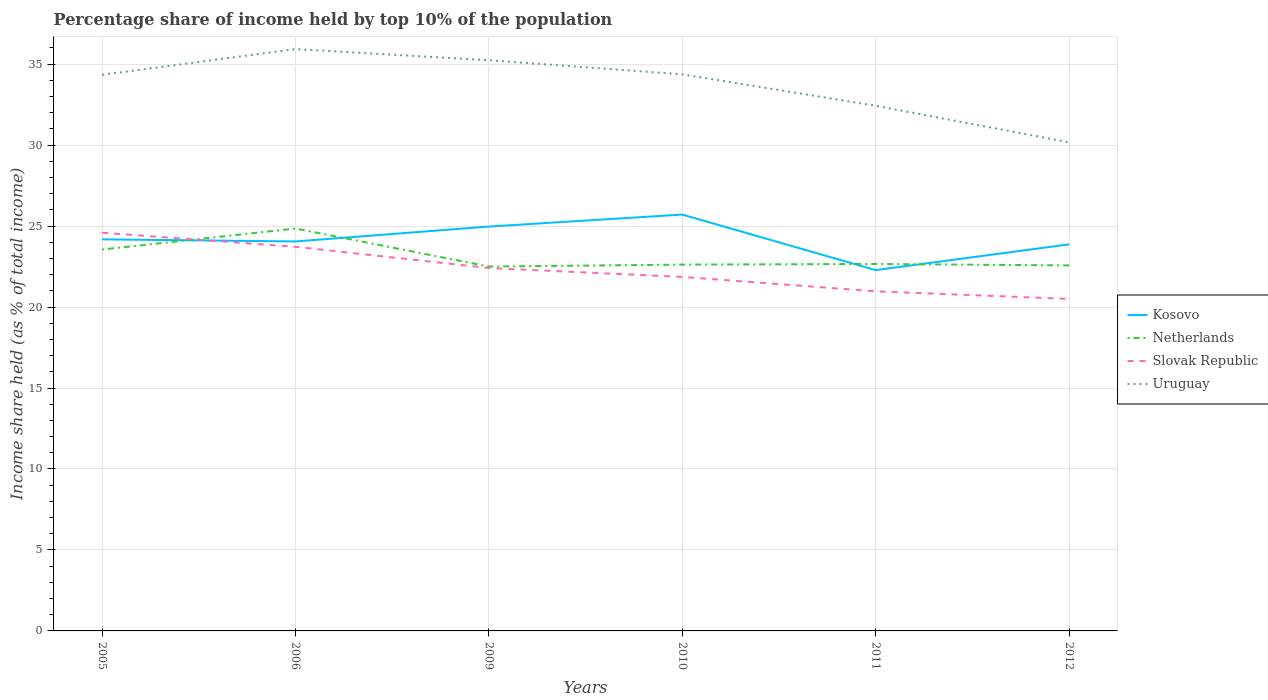Does the line corresponding to Uruguay intersect with the line corresponding to Kosovo?
Ensure brevity in your answer.  No. Is the number of lines equal to the number of legend labels?
Your response must be concise. Yes. Across all years, what is the maximum percentage share of income held by top 10% of the population in Kosovo?
Make the answer very short. 22.28. What is the total percentage share of income held by top 10% of the population in Slovak Republic in the graph?
Your response must be concise. 0.89. What is the difference between the highest and the second highest percentage share of income held by top 10% of the population in Slovak Republic?
Make the answer very short. 4.09. Is the percentage share of income held by top 10% of the population in Kosovo strictly greater than the percentage share of income held by top 10% of the population in Netherlands over the years?
Your answer should be very brief. No. How many lines are there?
Keep it short and to the point. 4. What is the difference between two consecutive major ticks on the Y-axis?
Your answer should be very brief. 5. Does the graph contain grids?
Ensure brevity in your answer.  Yes. Where does the legend appear in the graph?
Offer a very short reply. Center right. How are the legend labels stacked?
Offer a terse response. Vertical. What is the title of the graph?
Provide a succinct answer. Percentage share of income held by top 10% of the population. What is the label or title of the Y-axis?
Your answer should be very brief. Income share held (as % of total income). What is the Income share held (as % of total income) in Kosovo in 2005?
Your answer should be very brief. 24.18. What is the Income share held (as % of total income) of Netherlands in 2005?
Give a very brief answer. 23.55. What is the Income share held (as % of total income) in Slovak Republic in 2005?
Your answer should be compact. 24.59. What is the Income share held (as % of total income) of Uruguay in 2005?
Give a very brief answer. 34.34. What is the Income share held (as % of total income) in Kosovo in 2006?
Provide a succinct answer. 24.05. What is the Income share held (as % of total income) of Netherlands in 2006?
Keep it short and to the point. 24.85. What is the Income share held (as % of total income) of Slovak Republic in 2006?
Give a very brief answer. 23.72. What is the Income share held (as % of total income) in Uruguay in 2006?
Offer a terse response. 35.93. What is the Income share held (as % of total income) of Kosovo in 2009?
Make the answer very short. 24.97. What is the Income share held (as % of total income) in Slovak Republic in 2009?
Offer a very short reply. 22.41. What is the Income share held (as % of total income) of Uruguay in 2009?
Offer a terse response. 35.24. What is the Income share held (as % of total income) in Kosovo in 2010?
Your answer should be very brief. 25.71. What is the Income share held (as % of total income) in Netherlands in 2010?
Provide a short and direct response. 22.62. What is the Income share held (as % of total income) of Slovak Republic in 2010?
Provide a short and direct response. 21.86. What is the Income share held (as % of total income) of Uruguay in 2010?
Ensure brevity in your answer.  34.37. What is the Income share held (as % of total income) in Kosovo in 2011?
Ensure brevity in your answer.  22.28. What is the Income share held (as % of total income) in Netherlands in 2011?
Provide a succinct answer. 22.66. What is the Income share held (as % of total income) in Slovak Republic in 2011?
Give a very brief answer. 20.97. What is the Income share held (as % of total income) in Uruguay in 2011?
Offer a terse response. 32.43. What is the Income share held (as % of total income) in Kosovo in 2012?
Your response must be concise. 23.87. What is the Income share held (as % of total income) in Netherlands in 2012?
Provide a succinct answer. 22.57. What is the Income share held (as % of total income) of Uruguay in 2012?
Keep it short and to the point. 30.17. Across all years, what is the maximum Income share held (as % of total income) in Kosovo?
Your response must be concise. 25.71. Across all years, what is the maximum Income share held (as % of total income) in Netherlands?
Your response must be concise. 24.85. Across all years, what is the maximum Income share held (as % of total income) in Slovak Republic?
Offer a very short reply. 24.59. Across all years, what is the maximum Income share held (as % of total income) of Uruguay?
Your answer should be very brief. 35.93. Across all years, what is the minimum Income share held (as % of total income) in Kosovo?
Your answer should be very brief. 22.28. Across all years, what is the minimum Income share held (as % of total income) in Slovak Republic?
Ensure brevity in your answer.  20.5. Across all years, what is the minimum Income share held (as % of total income) of Uruguay?
Give a very brief answer. 30.17. What is the total Income share held (as % of total income) in Kosovo in the graph?
Your response must be concise. 145.06. What is the total Income share held (as % of total income) in Netherlands in the graph?
Offer a very short reply. 138.75. What is the total Income share held (as % of total income) in Slovak Republic in the graph?
Provide a short and direct response. 134.05. What is the total Income share held (as % of total income) in Uruguay in the graph?
Your answer should be compact. 202.48. What is the difference between the Income share held (as % of total income) in Kosovo in 2005 and that in 2006?
Offer a very short reply. 0.13. What is the difference between the Income share held (as % of total income) of Slovak Republic in 2005 and that in 2006?
Your answer should be very brief. 0.87. What is the difference between the Income share held (as % of total income) in Uruguay in 2005 and that in 2006?
Keep it short and to the point. -1.59. What is the difference between the Income share held (as % of total income) in Kosovo in 2005 and that in 2009?
Provide a short and direct response. -0.79. What is the difference between the Income share held (as % of total income) in Netherlands in 2005 and that in 2009?
Your answer should be compact. 1.05. What is the difference between the Income share held (as % of total income) in Slovak Republic in 2005 and that in 2009?
Provide a succinct answer. 2.18. What is the difference between the Income share held (as % of total income) of Uruguay in 2005 and that in 2009?
Make the answer very short. -0.9. What is the difference between the Income share held (as % of total income) of Kosovo in 2005 and that in 2010?
Keep it short and to the point. -1.53. What is the difference between the Income share held (as % of total income) in Slovak Republic in 2005 and that in 2010?
Offer a terse response. 2.73. What is the difference between the Income share held (as % of total income) in Uruguay in 2005 and that in 2010?
Your answer should be very brief. -0.03. What is the difference between the Income share held (as % of total income) in Kosovo in 2005 and that in 2011?
Keep it short and to the point. 1.9. What is the difference between the Income share held (as % of total income) of Netherlands in 2005 and that in 2011?
Your response must be concise. 0.89. What is the difference between the Income share held (as % of total income) in Slovak Republic in 2005 and that in 2011?
Offer a terse response. 3.62. What is the difference between the Income share held (as % of total income) in Uruguay in 2005 and that in 2011?
Provide a succinct answer. 1.91. What is the difference between the Income share held (as % of total income) of Kosovo in 2005 and that in 2012?
Offer a very short reply. 0.31. What is the difference between the Income share held (as % of total income) of Netherlands in 2005 and that in 2012?
Offer a very short reply. 0.98. What is the difference between the Income share held (as % of total income) of Slovak Republic in 2005 and that in 2012?
Make the answer very short. 4.09. What is the difference between the Income share held (as % of total income) in Uruguay in 2005 and that in 2012?
Your answer should be compact. 4.17. What is the difference between the Income share held (as % of total income) of Kosovo in 2006 and that in 2009?
Offer a terse response. -0.92. What is the difference between the Income share held (as % of total income) of Netherlands in 2006 and that in 2009?
Provide a succinct answer. 2.35. What is the difference between the Income share held (as % of total income) of Slovak Republic in 2006 and that in 2009?
Your answer should be compact. 1.31. What is the difference between the Income share held (as % of total income) in Uruguay in 2006 and that in 2009?
Offer a very short reply. 0.69. What is the difference between the Income share held (as % of total income) in Kosovo in 2006 and that in 2010?
Your response must be concise. -1.66. What is the difference between the Income share held (as % of total income) in Netherlands in 2006 and that in 2010?
Provide a succinct answer. 2.23. What is the difference between the Income share held (as % of total income) of Slovak Republic in 2006 and that in 2010?
Give a very brief answer. 1.86. What is the difference between the Income share held (as % of total income) in Uruguay in 2006 and that in 2010?
Ensure brevity in your answer.  1.56. What is the difference between the Income share held (as % of total income) in Kosovo in 2006 and that in 2011?
Offer a terse response. 1.77. What is the difference between the Income share held (as % of total income) in Netherlands in 2006 and that in 2011?
Your response must be concise. 2.19. What is the difference between the Income share held (as % of total income) in Slovak Republic in 2006 and that in 2011?
Make the answer very short. 2.75. What is the difference between the Income share held (as % of total income) in Kosovo in 2006 and that in 2012?
Give a very brief answer. 0.18. What is the difference between the Income share held (as % of total income) of Netherlands in 2006 and that in 2012?
Your answer should be compact. 2.28. What is the difference between the Income share held (as % of total income) in Slovak Republic in 2006 and that in 2012?
Keep it short and to the point. 3.22. What is the difference between the Income share held (as % of total income) of Uruguay in 2006 and that in 2012?
Offer a terse response. 5.76. What is the difference between the Income share held (as % of total income) of Kosovo in 2009 and that in 2010?
Your answer should be compact. -0.74. What is the difference between the Income share held (as % of total income) of Netherlands in 2009 and that in 2010?
Provide a succinct answer. -0.12. What is the difference between the Income share held (as % of total income) in Slovak Republic in 2009 and that in 2010?
Provide a succinct answer. 0.55. What is the difference between the Income share held (as % of total income) of Uruguay in 2009 and that in 2010?
Provide a succinct answer. 0.87. What is the difference between the Income share held (as % of total income) in Kosovo in 2009 and that in 2011?
Provide a short and direct response. 2.69. What is the difference between the Income share held (as % of total income) in Netherlands in 2009 and that in 2011?
Ensure brevity in your answer.  -0.16. What is the difference between the Income share held (as % of total income) of Slovak Republic in 2009 and that in 2011?
Provide a succinct answer. 1.44. What is the difference between the Income share held (as % of total income) of Uruguay in 2009 and that in 2011?
Your answer should be compact. 2.81. What is the difference between the Income share held (as % of total income) of Netherlands in 2009 and that in 2012?
Give a very brief answer. -0.07. What is the difference between the Income share held (as % of total income) of Slovak Republic in 2009 and that in 2012?
Ensure brevity in your answer.  1.91. What is the difference between the Income share held (as % of total income) in Uruguay in 2009 and that in 2012?
Give a very brief answer. 5.07. What is the difference between the Income share held (as % of total income) of Kosovo in 2010 and that in 2011?
Offer a terse response. 3.43. What is the difference between the Income share held (as % of total income) in Netherlands in 2010 and that in 2011?
Your answer should be compact. -0.04. What is the difference between the Income share held (as % of total income) of Slovak Republic in 2010 and that in 2011?
Ensure brevity in your answer.  0.89. What is the difference between the Income share held (as % of total income) of Uruguay in 2010 and that in 2011?
Keep it short and to the point. 1.94. What is the difference between the Income share held (as % of total income) in Kosovo in 2010 and that in 2012?
Offer a very short reply. 1.84. What is the difference between the Income share held (as % of total income) of Slovak Republic in 2010 and that in 2012?
Provide a succinct answer. 1.36. What is the difference between the Income share held (as % of total income) of Kosovo in 2011 and that in 2012?
Provide a succinct answer. -1.59. What is the difference between the Income share held (as % of total income) in Netherlands in 2011 and that in 2012?
Offer a very short reply. 0.09. What is the difference between the Income share held (as % of total income) in Slovak Republic in 2011 and that in 2012?
Give a very brief answer. 0.47. What is the difference between the Income share held (as % of total income) in Uruguay in 2011 and that in 2012?
Make the answer very short. 2.26. What is the difference between the Income share held (as % of total income) in Kosovo in 2005 and the Income share held (as % of total income) in Netherlands in 2006?
Offer a very short reply. -0.67. What is the difference between the Income share held (as % of total income) in Kosovo in 2005 and the Income share held (as % of total income) in Slovak Republic in 2006?
Make the answer very short. 0.46. What is the difference between the Income share held (as % of total income) of Kosovo in 2005 and the Income share held (as % of total income) of Uruguay in 2006?
Offer a very short reply. -11.75. What is the difference between the Income share held (as % of total income) of Netherlands in 2005 and the Income share held (as % of total income) of Slovak Republic in 2006?
Make the answer very short. -0.17. What is the difference between the Income share held (as % of total income) in Netherlands in 2005 and the Income share held (as % of total income) in Uruguay in 2006?
Provide a short and direct response. -12.38. What is the difference between the Income share held (as % of total income) of Slovak Republic in 2005 and the Income share held (as % of total income) of Uruguay in 2006?
Your response must be concise. -11.34. What is the difference between the Income share held (as % of total income) in Kosovo in 2005 and the Income share held (as % of total income) in Netherlands in 2009?
Your answer should be compact. 1.68. What is the difference between the Income share held (as % of total income) of Kosovo in 2005 and the Income share held (as % of total income) of Slovak Republic in 2009?
Your answer should be compact. 1.77. What is the difference between the Income share held (as % of total income) of Kosovo in 2005 and the Income share held (as % of total income) of Uruguay in 2009?
Your answer should be very brief. -11.06. What is the difference between the Income share held (as % of total income) in Netherlands in 2005 and the Income share held (as % of total income) in Slovak Republic in 2009?
Your response must be concise. 1.14. What is the difference between the Income share held (as % of total income) of Netherlands in 2005 and the Income share held (as % of total income) of Uruguay in 2009?
Offer a terse response. -11.69. What is the difference between the Income share held (as % of total income) in Slovak Republic in 2005 and the Income share held (as % of total income) in Uruguay in 2009?
Give a very brief answer. -10.65. What is the difference between the Income share held (as % of total income) in Kosovo in 2005 and the Income share held (as % of total income) in Netherlands in 2010?
Provide a short and direct response. 1.56. What is the difference between the Income share held (as % of total income) of Kosovo in 2005 and the Income share held (as % of total income) of Slovak Republic in 2010?
Your answer should be very brief. 2.32. What is the difference between the Income share held (as % of total income) in Kosovo in 2005 and the Income share held (as % of total income) in Uruguay in 2010?
Offer a very short reply. -10.19. What is the difference between the Income share held (as % of total income) of Netherlands in 2005 and the Income share held (as % of total income) of Slovak Republic in 2010?
Your answer should be compact. 1.69. What is the difference between the Income share held (as % of total income) in Netherlands in 2005 and the Income share held (as % of total income) in Uruguay in 2010?
Offer a terse response. -10.82. What is the difference between the Income share held (as % of total income) in Slovak Republic in 2005 and the Income share held (as % of total income) in Uruguay in 2010?
Your answer should be compact. -9.78. What is the difference between the Income share held (as % of total income) in Kosovo in 2005 and the Income share held (as % of total income) in Netherlands in 2011?
Your response must be concise. 1.52. What is the difference between the Income share held (as % of total income) of Kosovo in 2005 and the Income share held (as % of total income) of Slovak Republic in 2011?
Your answer should be compact. 3.21. What is the difference between the Income share held (as % of total income) of Kosovo in 2005 and the Income share held (as % of total income) of Uruguay in 2011?
Your response must be concise. -8.25. What is the difference between the Income share held (as % of total income) of Netherlands in 2005 and the Income share held (as % of total income) of Slovak Republic in 2011?
Give a very brief answer. 2.58. What is the difference between the Income share held (as % of total income) of Netherlands in 2005 and the Income share held (as % of total income) of Uruguay in 2011?
Provide a short and direct response. -8.88. What is the difference between the Income share held (as % of total income) of Slovak Republic in 2005 and the Income share held (as % of total income) of Uruguay in 2011?
Provide a succinct answer. -7.84. What is the difference between the Income share held (as % of total income) of Kosovo in 2005 and the Income share held (as % of total income) of Netherlands in 2012?
Ensure brevity in your answer.  1.61. What is the difference between the Income share held (as % of total income) in Kosovo in 2005 and the Income share held (as % of total income) in Slovak Republic in 2012?
Provide a succinct answer. 3.68. What is the difference between the Income share held (as % of total income) in Kosovo in 2005 and the Income share held (as % of total income) in Uruguay in 2012?
Give a very brief answer. -5.99. What is the difference between the Income share held (as % of total income) of Netherlands in 2005 and the Income share held (as % of total income) of Slovak Republic in 2012?
Keep it short and to the point. 3.05. What is the difference between the Income share held (as % of total income) of Netherlands in 2005 and the Income share held (as % of total income) of Uruguay in 2012?
Give a very brief answer. -6.62. What is the difference between the Income share held (as % of total income) in Slovak Republic in 2005 and the Income share held (as % of total income) in Uruguay in 2012?
Offer a very short reply. -5.58. What is the difference between the Income share held (as % of total income) in Kosovo in 2006 and the Income share held (as % of total income) in Netherlands in 2009?
Your answer should be very brief. 1.55. What is the difference between the Income share held (as % of total income) in Kosovo in 2006 and the Income share held (as % of total income) in Slovak Republic in 2009?
Provide a succinct answer. 1.64. What is the difference between the Income share held (as % of total income) of Kosovo in 2006 and the Income share held (as % of total income) of Uruguay in 2009?
Make the answer very short. -11.19. What is the difference between the Income share held (as % of total income) of Netherlands in 2006 and the Income share held (as % of total income) of Slovak Republic in 2009?
Keep it short and to the point. 2.44. What is the difference between the Income share held (as % of total income) in Netherlands in 2006 and the Income share held (as % of total income) in Uruguay in 2009?
Offer a very short reply. -10.39. What is the difference between the Income share held (as % of total income) in Slovak Republic in 2006 and the Income share held (as % of total income) in Uruguay in 2009?
Your response must be concise. -11.52. What is the difference between the Income share held (as % of total income) in Kosovo in 2006 and the Income share held (as % of total income) in Netherlands in 2010?
Ensure brevity in your answer.  1.43. What is the difference between the Income share held (as % of total income) of Kosovo in 2006 and the Income share held (as % of total income) of Slovak Republic in 2010?
Make the answer very short. 2.19. What is the difference between the Income share held (as % of total income) of Kosovo in 2006 and the Income share held (as % of total income) of Uruguay in 2010?
Make the answer very short. -10.32. What is the difference between the Income share held (as % of total income) of Netherlands in 2006 and the Income share held (as % of total income) of Slovak Republic in 2010?
Provide a short and direct response. 2.99. What is the difference between the Income share held (as % of total income) in Netherlands in 2006 and the Income share held (as % of total income) in Uruguay in 2010?
Your answer should be compact. -9.52. What is the difference between the Income share held (as % of total income) in Slovak Republic in 2006 and the Income share held (as % of total income) in Uruguay in 2010?
Provide a short and direct response. -10.65. What is the difference between the Income share held (as % of total income) in Kosovo in 2006 and the Income share held (as % of total income) in Netherlands in 2011?
Provide a short and direct response. 1.39. What is the difference between the Income share held (as % of total income) of Kosovo in 2006 and the Income share held (as % of total income) of Slovak Republic in 2011?
Your response must be concise. 3.08. What is the difference between the Income share held (as % of total income) in Kosovo in 2006 and the Income share held (as % of total income) in Uruguay in 2011?
Offer a terse response. -8.38. What is the difference between the Income share held (as % of total income) of Netherlands in 2006 and the Income share held (as % of total income) of Slovak Republic in 2011?
Your response must be concise. 3.88. What is the difference between the Income share held (as % of total income) in Netherlands in 2006 and the Income share held (as % of total income) in Uruguay in 2011?
Keep it short and to the point. -7.58. What is the difference between the Income share held (as % of total income) in Slovak Republic in 2006 and the Income share held (as % of total income) in Uruguay in 2011?
Your answer should be very brief. -8.71. What is the difference between the Income share held (as % of total income) in Kosovo in 2006 and the Income share held (as % of total income) in Netherlands in 2012?
Your response must be concise. 1.48. What is the difference between the Income share held (as % of total income) of Kosovo in 2006 and the Income share held (as % of total income) of Slovak Republic in 2012?
Ensure brevity in your answer.  3.55. What is the difference between the Income share held (as % of total income) of Kosovo in 2006 and the Income share held (as % of total income) of Uruguay in 2012?
Your answer should be very brief. -6.12. What is the difference between the Income share held (as % of total income) of Netherlands in 2006 and the Income share held (as % of total income) of Slovak Republic in 2012?
Provide a succinct answer. 4.35. What is the difference between the Income share held (as % of total income) of Netherlands in 2006 and the Income share held (as % of total income) of Uruguay in 2012?
Provide a short and direct response. -5.32. What is the difference between the Income share held (as % of total income) of Slovak Republic in 2006 and the Income share held (as % of total income) of Uruguay in 2012?
Offer a very short reply. -6.45. What is the difference between the Income share held (as % of total income) of Kosovo in 2009 and the Income share held (as % of total income) of Netherlands in 2010?
Give a very brief answer. 2.35. What is the difference between the Income share held (as % of total income) in Kosovo in 2009 and the Income share held (as % of total income) in Slovak Republic in 2010?
Keep it short and to the point. 3.11. What is the difference between the Income share held (as % of total income) of Kosovo in 2009 and the Income share held (as % of total income) of Uruguay in 2010?
Offer a very short reply. -9.4. What is the difference between the Income share held (as % of total income) in Netherlands in 2009 and the Income share held (as % of total income) in Slovak Republic in 2010?
Offer a very short reply. 0.64. What is the difference between the Income share held (as % of total income) in Netherlands in 2009 and the Income share held (as % of total income) in Uruguay in 2010?
Make the answer very short. -11.87. What is the difference between the Income share held (as % of total income) in Slovak Republic in 2009 and the Income share held (as % of total income) in Uruguay in 2010?
Provide a short and direct response. -11.96. What is the difference between the Income share held (as % of total income) in Kosovo in 2009 and the Income share held (as % of total income) in Netherlands in 2011?
Offer a terse response. 2.31. What is the difference between the Income share held (as % of total income) of Kosovo in 2009 and the Income share held (as % of total income) of Uruguay in 2011?
Your response must be concise. -7.46. What is the difference between the Income share held (as % of total income) in Netherlands in 2009 and the Income share held (as % of total income) in Slovak Republic in 2011?
Ensure brevity in your answer.  1.53. What is the difference between the Income share held (as % of total income) in Netherlands in 2009 and the Income share held (as % of total income) in Uruguay in 2011?
Ensure brevity in your answer.  -9.93. What is the difference between the Income share held (as % of total income) in Slovak Republic in 2009 and the Income share held (as % of total income) in Uruguay in 2011?
Your response must be concise. -10.02. What is the difference between the Income share held (as % of total income) of Kosovo in 2009 and the Income share held (as % of total income) of Slovak Republic in 2012?
Your answer should be compact. 4.47. What is the difference between the Income share held (as % of total income) in Kosovo in 2009 and the Income share held (as % of total income) in Uruguay in 2012?
Your answer should be very brief. -5.2. What is the difference between the Income share held (as % of total income) in Netherlands in 2009 and the Income share held (as % of total income) in Uruguay in 2012?
Keep it short and to the point. -7.67. What is the difference between the Income share held (as % of total income) in Slovak Republic in 2009 and the Income share held (as % of total income) in Uruguay in 2012?
Your answer should be compact. -7.76. What is the difference between the Income share held (as % of total income) in Kosovo in 2010 and the Income share held (as % of total income) in Netherlands in 2011?
Your answer should be very brief. 3.05. What is the difference between the Income share held (as % of total income) in Kosovo in 2010 and the Income share held (as % of total income) in Slovak Republic in 2011?
Give a very brief answer. 4.74. What is the difference between the Income share held (as % of total income) in Kosovo in 2010 and the Income share held (as % of total income) in Uruguay in 2011?
Your answer should be compact. -6.72. What is the difference between the Income share held (as % of total income) in Netherlands in 2010 and the Income share held (as % of total income) in Slovak Republic in 2011?
Ensure brevity in your answer.  1.65. What is the difference between the Income share held (as % of total income) of Netherlands in 2010 and the Income share held (as % of total income) of Uruguay in 2011?
Offer a very short reply. -9.81. What is the difference between the Income share held (as % of total income) of Slovak Republic in 2010 and the Income share held (as % of total income) of Uruguay in 2011?
Your answer should be very brief. -10.57. What is the difference between the Income share held (as % of total income) in Kosovo in 2010 and the Income share held (as % of total income) in Netherlands in 2012?
Your answer should be compact. 3.14. What is the difference between the Income share held (as % of total income) in Kosovo in 2010 and the Income share held (as % of total income) in Slovak Republic in 2012?
Provide a succinct answer. 5.21. What is the difference between the Income share held (as % of total income) of Kosovo in 2010 and the Income share held (as % of total income) of Uruguay in 2012?
Your answer should be very brief. -4.46. What is the difference between the Income share held (as % of total income) of Netherlands in 2010 and the Income share held (as % of total income) of Slovak Republic in 2012?
Offer a terse response. 2.12. What is the difference between the Income share held (as % of total income) in Netherlands in 2010 and the Income share held (as % of total income) in Uruguay in 2012?
Provide a succinct answer. -7.55. What is the difference between the Income share held (as % of total income) in Slovak Republic in 2010 and the Income share held (as % of total income) in Uruguay in 2012?
Provide a succinct answer. -8.31. What is the difference between the Income share held (as % of total income) of Kosovo in 2011 and the Income share held (as % of total income) of Netherlands in 2012?
Your answer should be compact. -0.29. What is the difference between the Income share held (as % of total income) of Kosovo in 2011 and the Income share held (as % of total income) of Slovak Republic in 2012?
Give a very brief answer. 1.78. What is the difference between the Income share held (as % of total income) in Kosovo in 2011 and the Income share held (as % of total income) in Uruguay in 2012?
Your response must be concise. -7.89. What is the difference between the Income share held (as % of total income) of Netherlands in 2011 and the Income share held (as % of total income) of Slovak Republic in 2012?
Offer a terse response. 2.16. What is the difference between the Income share held (as % of total income) of Netherlands in 2011 and the Income share held (as % of total income) of Uruguay in 2012?
Provide a succinct answer. -7.51. What is the average Income share held (as % of total income) in Kosovo per year?
Offer a very short reply. 24.18. What is the average Income share held (as % of total income) of Netherlands per year?
Your response must be concise. 23.12. What is the average Income share held (as % of total income) of Slovak Republic per year?
Make the answer very short. 22.34. What is the average Income share held (as % of total income) of Uruguay per year?
Your answer should be compact. 33.75. In the year 2005, what is the difference between the Income share held (as % of total income) in Kosovo and Income share held (as % of total income) in Netherlands?
Provide a short and direct response. 0.63. In the year 2005, what is the difference between the Income share held (as % of total income) in Kosovo and Income share held (as % of total income) in Slovak Republic?
Keep it short and to the point. -0.41. In the year 2005, what is the difference between the Income share held (as % of total income) of Kosovo and Income share held (as % of total income) of Uruguay?
Give a very brief answer. -10.16. In the year 2005, what is the difference between the Income share held (as % of total income) in Netherlands and Income share held (as % of total income) in Slovak Republic?
Make the answer very short. -1.04. In the year 2005, what is the difference between the Income share held (as % of total income) in Netherlands and Income share held (as % of total income) in Uruguay?
Your answer should be compact. -10.79. In the year 2005, what is the difference between the Income share held (as % of total income) in Slovak Republic and Income share held (as % of total income) in Uruguay?
Make the answer very short. -9.75. In the year 2006, what is the difference between the Income share held (as % of total income) in Kosovo and Income share held (as % of total income) in Slovak Republic?
Your response must be concise. 0.33. In the year 2006, what is the difference between the Income share held (as % of total income) in Kosovo and Income share held (as % of total income) in Uruguay?
Ensure brevity in your answer.  -11.88. In the year 2006, what is the difference between the Income share held (as % of total income) in Netherlands and Income share held (as % of total income) in Slovak Republic?
Ensure brevity in your answer.  1.13. In the year 2006, what is the difference between the Income share held (as % of total income) of Netherlands and Income share held (as % of total income) of Uruguay?
Give a very brief answer. -11.08. In the year 2006, what is the difference between the Income share held (as % of total income) in Slovak Republic and Income share held (as % of total income) in Uruguay?
Provide a succinct answer. -12.21. In the year 2009, what is the difference between the Income share held (as % of total income) in Kosovo and Income share held (as % of total income) in Netherlands?
Make the answer very short. 2.47. In the year 2009, what is the difference between the Income share held (as % of total income) of Kosovo and Income share held (as % of total income) of Slovak Republic?
Provide a succinct answer. 2.56. In the year 2009, what is the difference between the Income share held (as % of total income) in Kosovo and Income share held (as % of total income) in Uruguay?
Your answer should be very brief. -10.27. In the year 2009, what is the difference between the Income share held (as % of total income) in Netherlands and Income share held (as % of total income) in Slovak Republic?
Your answer should be compact. 0.09. In the year 2009, what is the difference between the Income share held (as % of total income) of Netherlands and Income share held (as % of total income) of Uruguay?
Your answer should be very brief. -12.74. In the year 2009, what is the difference between the Income share held (as % of total income) in Slovak Republic and Income share held (as % of total income) in Uruguay?
Give a very brief answer. -12.83. In the year 2010, what is the difference between the Income share held (as % of total income) of Kosovo and Income share held (as % of total income) of Netherlands?
Ensure brevity in your answer.  3.09. In the year 2010, what is the difference between the Income share held (as % of total income) in Kosovo and Income share held (as % of total income) in Slovak Republic?
Offer a terse response. 3.85. In the year 2010, what is the difference between the Income share held (as % of total income) in Kosovo and Income share held (as % of total income) in Uruguay?
Offer a very short reply. -8.66. In the year 2010, what is the difference between the Income share held (as % of total income) of Netherlands and Income share held (as % of total income) of Slovak Republic?
Provide a short and direct response. 0.76. In the year 2010, what is the difference between the Income share held (as % of total income) in Netherlands and Income share held (as % of total income) in Uruguay?
Provide a succinct answer. -11.75. In the year 2010, what is the difference between the Income share held (as % of total income) in Slovak Republic and Income share held (as % of total income) in Uruguay?
Ensure brevity in your answer.  -12.51. In the year 2011, what is the difference between the Income share held (as % of total income) of Kosovo and Income share held (as % of total income) of Netherlands?
Make the answer very short. -0.38. In the year 2011, what is the difference between the Income share held (as % of total income) of Kosovo and Income share held (as % of total income) of Slovak Republic?
Your answer should be compact. 1.31. In the year 2011, what is the difference between the Income share held (as % of total income) of Kosovo and Income share held (as % of total income) of Uruguay?
Keep it short and to the point. -10.15. In the year 2011, what is the difference between the Income share held (as % of total income) in Netherlands and Income share held (as % of total income) in Slovak Republic?
Your answer should be compact. 1.69. In the year 2011, what is the difference between the Income share held (as % of total income) in Netherlands and Income share held (as % of total income) in Uruguay?
Offer a very short reply. -9.77. In the year 2011, what is the difference between the Income share held (as % of total income) in Slovak Republic and Income share held (as % of total income) in Uruguay?
Provide a short and direct response. -11.46. In the year 2012, what is the difference between the Income share held (as % of total income) in Kosovo and Income share held (as % of total income) in Slovak Republic?
Your answer should be compact. 3.37. In the year 2012, what is the difference between the Income share held (as % of total income) of Kosovo and Income share held (as % of total income) of Uruguay?
Make the answer very short. -6.3. In the year 2012, what is the difference between the Income share held (as % of total income) in Netherlands and Income share held (as % of total income) in Slovak Republic?
Ensure brevity in your answer.  2.07. In the year 2012, what is the difference between the Income share held (as % of total income) of Netherlands and Income share held (as % of total income) of Uruguay?
Keep it short and to the point. -7.6. In the year 2012, what is the difference between the Income share held (as % of total income) of Slovak Republic and Income share held (as % of total income) of Uruguay?
Make the answer very short. -9.67. What is the ratio of the Income share held (as % of total income) in Kosovo in 2005 to that in 2006?
Provide a succinct answer. 1.01. What is the ratio of the Income share held (as % of total income) of Netherlands in 2005 to that in 2006?
Provide a short and direct response. 0.95. What is the ratio of the Income share held (as % of total income) in Slovak Republic in 2005 to that in 2006?
Offer a terse response. 1.04. What is the ratio of the Income share held (as % of total income) of Uruguay in 2005 to that in 2006?
Your answer should be compact. 0.96. What is the ratio of the Income share held (as % of total income) of Kosovo in 2005 to that in 2009?
Your response must be concise. 0.97. What is the ratio of the Income share held (as % of total income) of Netherlands in 2005 to that in 2009?
Make the answer very short. 1.05. What is the ratio of the Income share held (as % of total income) in Slovak Republic in 2005 to that in 2009?
Give a very brief answer. 1.1. What is the ratio of the Income share held (as % of total income) of Uruguay in 2005 to that in 2009?
Ensure brevity in your answer.  0.97. What is the ratio of the Income share held (as % of total income) in Kosovo in 2005 to that in 2010?
Give a very brief answer. 0.94. What is the ratio of the Income share held (as % of total income) in Netherlands in 2005 to that in 2010?
Provide a succinct answer. 1.04. What is the ratio of the Income share held (as % of total income) of Slovak Republic in 2005 to that in 2010?
Ensure brevity in your answer.  1.12. What is the ratio of the Income share held (as % of total income) of Uruguay in 2005 to that in 2010?
Your response must be concise. 1. What is the ratio of the Income share held (as % of total income) in Kosovo in 2005 to that in 2011?
Ensure brevity in your answer.  1.09. What is the ratio of the Income share held (as % of total income) of Netherlands in 2005 to that in 2011?
Ensure brevity in your answer.  1.04. What is the ratio of the Income share held (as % of total income) in Slovak Republic in 2005 to that in 2011?
Ensure brevity in your answer.  1.17. What is the ratio of the Income share held (as % of total income) in Uruguay in 2005 to that in 2011?
Keep it short and to the point. 1.06. What is the ratio of the Income share held (as % of total income) in Kosovo in 2005 to that in 2012?
Your answer should be very brief. 1.01. What is the ratio of the Income share held (as % of total income) in Netherlands in 2005 to that in 2012?
Give a very brief answer. 1.04. What is the ratio of the Income share held (as % of total income) of Slovak Republic in 2005 to that in 2012?
Provide a short and direct response. 1.2. What is the ratio of the Income share held (as % of total income) in Uruguay in 2005 to that in 2012?
Make the answer very short. 1.14. What is the ratio of the Income share held (as % of total income) in Kosovo in 2006 to that in 2009?
Ensure brevity in your answer.  0.96. What is the ratio of the Income share held (as % of total income) in Netherlands in 2006 to that in 2009?
Keep it short and to the point. 1.1. What is the ratio of the Income share held (as % of total income) of Slovak Republic in 2006 to that in 2009?
Your answer should be very brief. 1.06. What is the ratio of the Income share held (as % of total income) of Uruguay in 2006 to that in 2009?
Give a very brief answer. 1.02. What is the ratio of the Income share held (as % of total income) of Kosovo in 2006 to that in 2010?
Your answer should be very brief. 0.94. What is the ratio of the Income share held (as % of total income) of Netherlands in 2006 to that in 2010?
Your response must be concise. 1.1. What is the ratio of the Income share held (as % of total income) of Slovak Republic in 2006 to that in 2010?
Offer a very short reply. 1.09. What is the ratio of the Income share held (as % of total income) in Uruguay in 2006 to that in 2010?
Ensure brevity in your answer.  1.05. What is the ratio of the Income share held (as % of total income) in Kosovo in 2006 to that in 2011?
Make the answer very short. 1.08. What is the ratio of the Income share held (as % of total income) in Netherlands in 2006 to that in 2011?
Your answer should be very brief. 1.1. What is the ratio of the Income share held (as % of total income) of Slovak Republic in 2006 to that in 2011?
Make the answer very short. 1.13. What is the ratio of the Income share held (as % of total income) in Uruguay in 2006 to that in 2011?
Provide a short and direct response. 1.11. What is the ratio of the Income share held (as % of total income) in Kosovo in 2006 to that in 2012?
Ensure brevity in your answer.  1.01. What is the ratio of the Income share held (as % of total income) in Netherlands in 2006 to that in 2012?
Ensure brevity in your answer.  1.1. What is the ratio of the Income share held (as % of total income) in Slovak Republic in 2006 to that in 2012?
Ensure brevity in your answer.  1.16. What is the ratio of the Income share held (as % of total income) in Uruguay in 2006 to that in 2012?
Offer a very short reply. 1.19. What is the ratio of the Income share held (as % of total income) in Kosovo in 2009 to that in 2010?
Provide a short and direct response. 0.97. What is the ratio of the Income share held (as % of total income) of Netherlands in 2009 to that in 2010?
Provide a succinct answer. 0.99. What is the ratio of the Income share held (as % of total income) in Slovak Republic in 2009 to that in 2010?
Your answer should be very brief. 1.03. What is the ratio of the Income share held (as % of total income) of Uruguay in 2009 to that in 2010?
Give a very brief answer. 1.03. What is the ratio of the Income share held (as % of total income) of Kosovo in 2009 to that in 2011?
Make the answer very short. 1.12. What is the ratio of the Income share held (as % of total income) of Slovak Republic in 2009 to that in 2011?
Keep it short and to the point. 1.07. What is the ratio of the Income share held (as % of total income) of Uruguay in 2009 to that in 2011?
Your answer should be compact. 1.09. What is the ratio of the Income share held (as % of total income) in Kosovo in 2009 to that in 2012?
Your answer should be compact. 1.05. What is the ratio of the Income share held (as % of total income) in Netherlands in 2009 to that in 2012?
Make the answer very short. 1. What is the ratio of the Income share held (as % of total income) in Slovak Republic in 2009 to that in 2012?
Your response must be concise. 1.09. What is the ratio of the Income share held (as % of total income) in Uruguay in 2009 to that in 2012?
Your answer should be compact. 1.17. What is the ratio of the Income share held (as % of total income) in Kosovo in 2010 to that in 2011?
Offer a very short reply. 1.15. What is the ratio of the Income share held (as % of total income) in Slovak Republic in 2010 to that in 2011?
Your answer should be compact. 1.04. What is the ratio of the Income share held (as % of total income) in Uruguay in 2010 to that in 2011?
Offer a very short reply. 1.06. What is the ratio of the Income share held (as % of total income) in Kosovo in 2010 to that in 2012?
Your answer should be very brief. 1.08. What is the ratio of the Income share held (as % of total income) of Slovak Republic in 2010 to that in 2012?
Offer a terse response. 1.07. What is the ratio of the Income share held (as % of total income) in Uruguay in 2010 to that in 2012?
Provide a succinct answer. 1.14. What is the ratio of the Income share held (as % of total income) in Kosovo in 2011 to that in 2012?
Keep it short and to the point. 0.93. What is the ratio of the Income share held (as % of total income) of Slovak Republic in 2011 to that in 2012?
Your answer should be compact. 1.02. What is the ratio of the Income share held (as % of total income) of Uruguay in 2011 to that in 2012?
Ensure brevity in your answer.  1.07. What is the difference between the highest and the second highest Income share held (as % of total income) in Kosovo?
Offer a terse response. 0.74. What is the difference between the highest and the second highest Income share held (as % of total income) of Netherlands?
Your answer should be very brief. 1.3. What is the difference between the highest and the second highest Income share held (as % of total income) of Slovak Republic?
Make the answer very short. 0.87. What is the difference between the highest and the second highest Income share held (as % of total income) of Uruguay?
Make the answer very short. 0.69. What is the difference between the highest and the lowest Income share held (as % of total income) in Kosovo?
Your answer should be compact. 3.43. What is the difference between the highest and the lowest Income share held (as % of total income) in Netherlands?
Offer a terse response. 2.35. What is the difference between the highest and the lowest Income share held (as % of total income) of Slovak Republic?
Provide a short and direct response. 4.09. What is the difference between the highest and the lowest Income share held (as % of total income) in Uruguay?
Offer a very short reply. 5.76. 